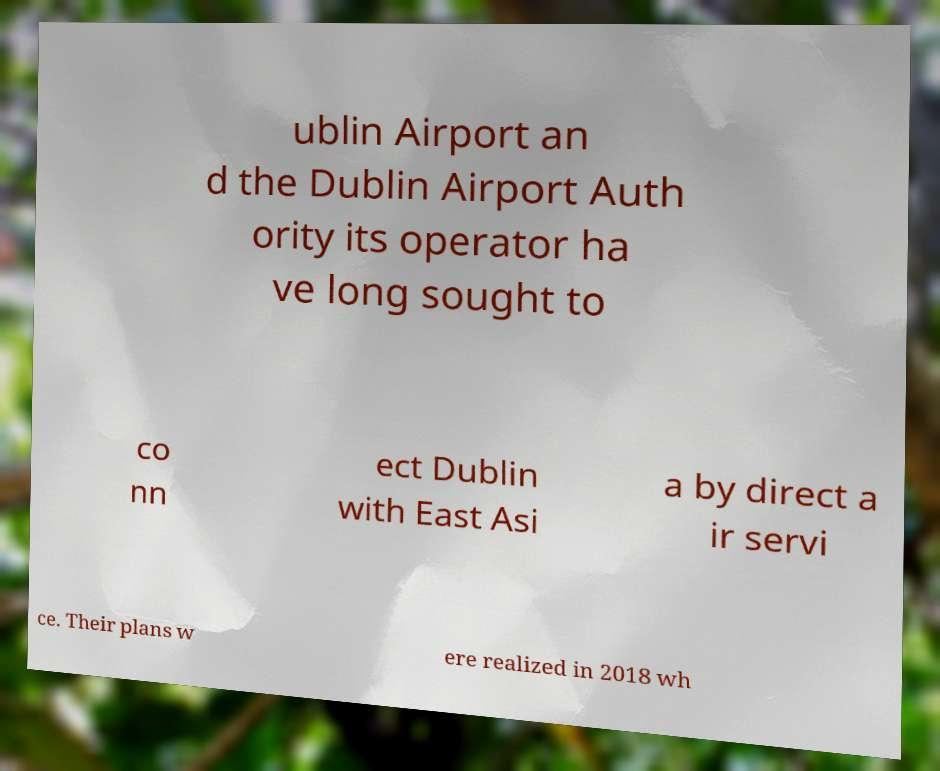Can you accurately transcribe the text from the provided image for me? ublin Airport an d the Dublin Airport Auth ority its operator ha ve long sought to co nn ect Dublin with East Asi a by direct a ir servi ce. Their plans w ere realized in 2018 wh 